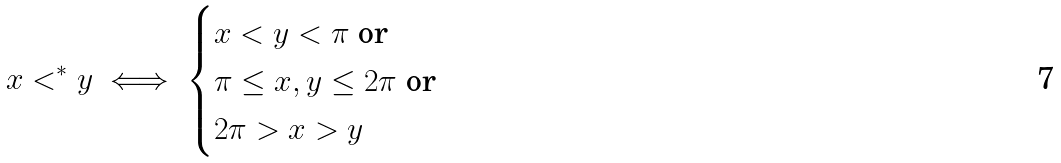Convert formula to latex. <formula><loc_0><loc_0><loc_500><loc_500>x < ^ { * } y \iff \begin{cases} \text {$x<y<\pi$ or} \\ \text {$\pi \leq x,y\leq 2\pi$ or } \\ \text {$2\pi > x > y$} \end{cases}</formula> 